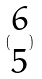<formula> <loc_0><loc_0><loc_500><loc_500>( \begin{matrix} 6 \\ 5 \end{matrix} )</formula> 